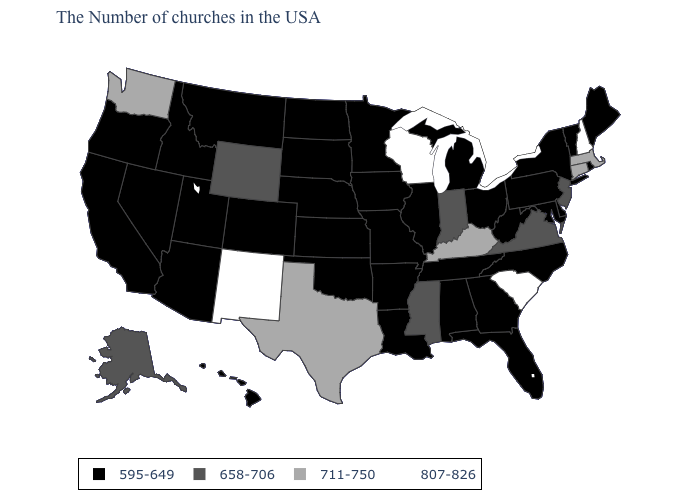What is the value of Idaho?
Give a very brief answer. 595-649. Name the states that have a value in the range 595-649?
Keep it brief. Maine, Rhode Island, Vermont, New York, Delaware, Maryland, Pennsylvania, North Carolina, West Virginia, Ohio, Florida, Georgia, Michigan, Alabama, Tennessee, Illinois, Louisiana, Missouri, Arkansas, Minnesota, Iowa, Kansas, Nebraska, Oklahoma, South Dakota, North Dakota, Colorado, Utah, Montana, Arizona, Idaho, Nevada, California, Oregon, Hawaii. Which states hav the highest value in the MidWest?
Be succinct. Wisconsin. Does the first symbol in the legend represent the smallest category?
Give a very brief answer. Yes. Name the states that have a value in the range 807-826?
Concise answer only. New Hampshire, South Carolina, Wisconsin, New Mexico. Which states hav the highest value in the West?
Short answer required. New Mexico. Among the states that border Iowa , which have the lowest value?
Give a very brief answer. Illinois, Missouri, Minnesota, Nebraska, South Dakota. What is the value of California?
Give a very brief answer. 595-649. Does Indiana have the same value as New Jersey?
Be succinct. Yes. Name the states that have a value in the range 711-750?
Give a very brief answer. Massachusetts, Connecticut, Kentucky, Texas, Washington. Among the states that border New York , which have the highest value?
Concise answer only. Massachusetts, Connecticut. Among the states that border North Dakota , which have the lowest value?
Short answer required. Minnesota, South Dakota, Montana. What is the highest value in the MidWest ?
Concise answer only. 807-826. Does Wisconsin have the lowest value in the MidWest?
Concise answer only. No. What is the lowest value in the USA?
Give a very brief answer. 595-649. 